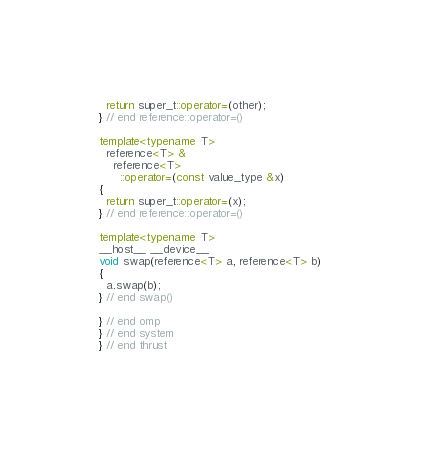<code> <loc_0><loc_0><loc_500><loc_500><_C++_>  return super_t::operator=(other);
} // end reference::operator=()

template<typename T>
  reference<T> &
    reference<T>
      ::operator=(const value_type &x)
{
  return super_t::operator=(x);
} // end reference::operator=()

template<typename T>
__host__ __device__
void swap(reference<T> a, reference<T> b)
{
  a.swap(b);
} // end swap()

} // end omp
} // end system
} // end thrust

</code> 